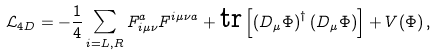Convert formula to latex. <formula><loc_0><loc_0><loc_500><loc_500>\mathcal { L } _ { 4 D } = - \frac { 1 } { 4 } \sum _ { i = L , R } F _ { i \mu \nu } ^ { a } F ^ { i \mu \nu a } + \text {tr} \left [ \left ( D _ { \mu } \Phi \right ) ^ { \dagger } \left ( D _ { \mu } \Phi \right ) \right ] + V ( \Phi ) \, ,</formula> 